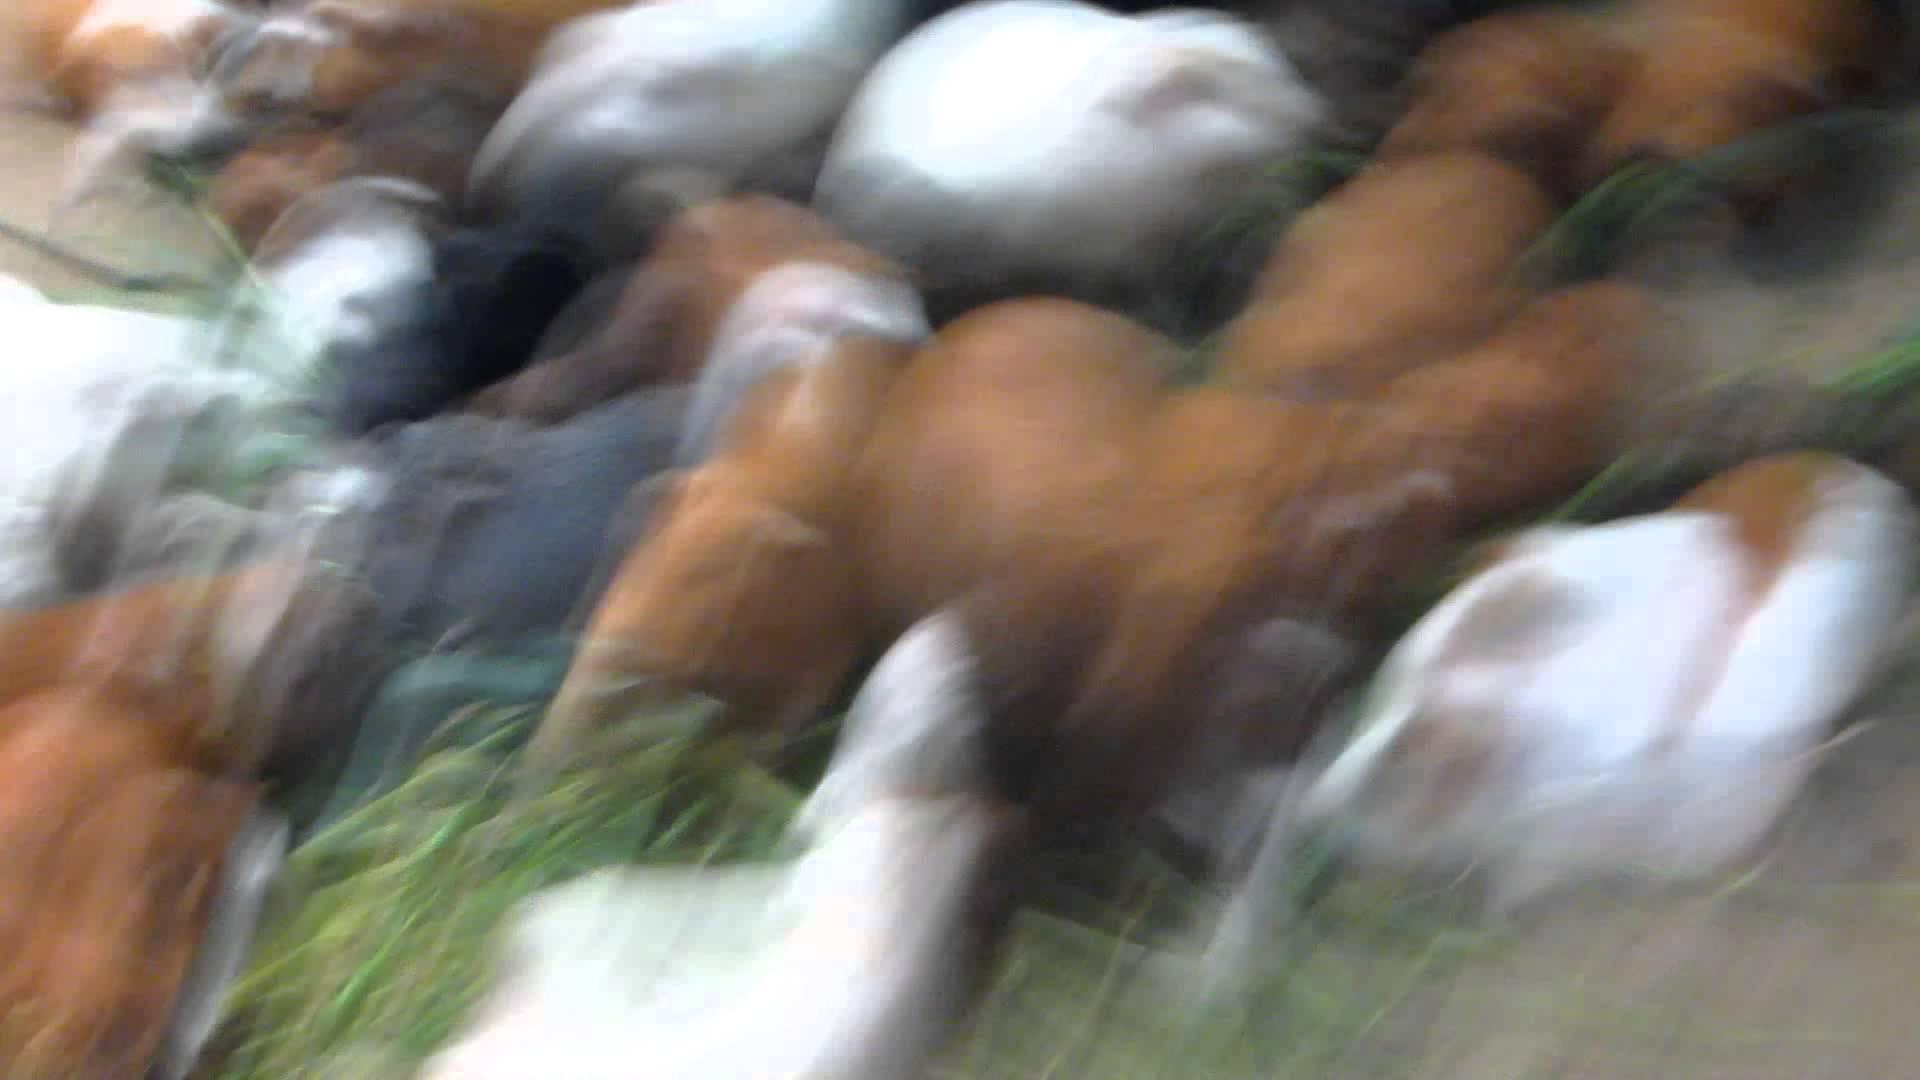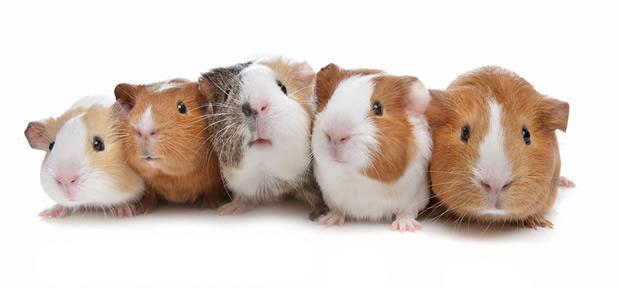The first image is the image on the left, the second image is the image on the right. Assess this claim about the two images: "An image shows exactly two hamsters side by side.". Correct or not? Answer yes or no. No. The first image is the image on the left, the second image is the image on the right. Examine the images to the left and right. Is the description "One image contains only two guinea pigs." accurate? Answer yes or no. No. 